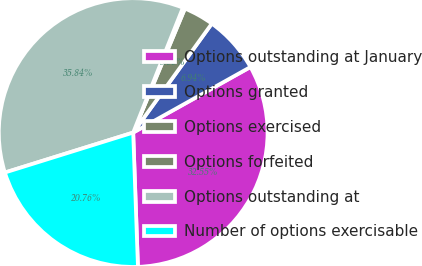Convert chart. <chart><loc_0><loc_0><loc_500><loc_500><pie_chart><fcel>Options outstanding at January<fcel>Options granted<fcel>Options exercised<fcel>Options forfeited<fcel>Options outstanding at<fcel>Number of options exercisable<nl><fcel>32.55%<fcel>6.94%<fcel>3.66%<fcel>0.26%<fcel>35.84%<fcel>20.76%<nl></chart> 